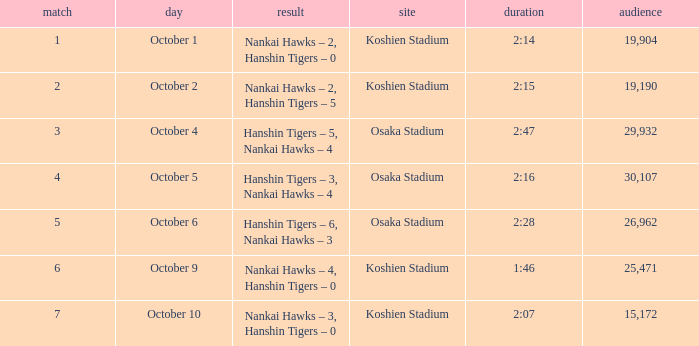How many games have an Attendance of 19,190? 1.0. 